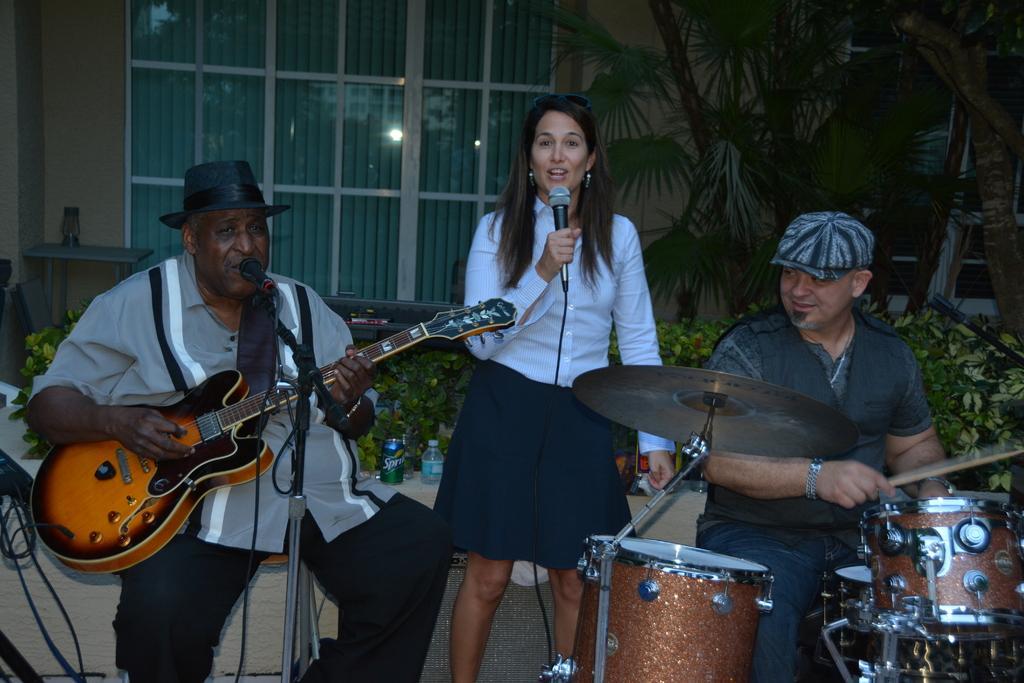In one or two sentences, can you explain what this image depicts? In this picture we can see a woman who is standing and singing on the mike. On left side we can see a man who is sitting on the chair and playing guitar. He wear a cap. On the right side we see a one more person and he is playing drums. On the background we can see some trees. And this is the wall and these are the plants. 